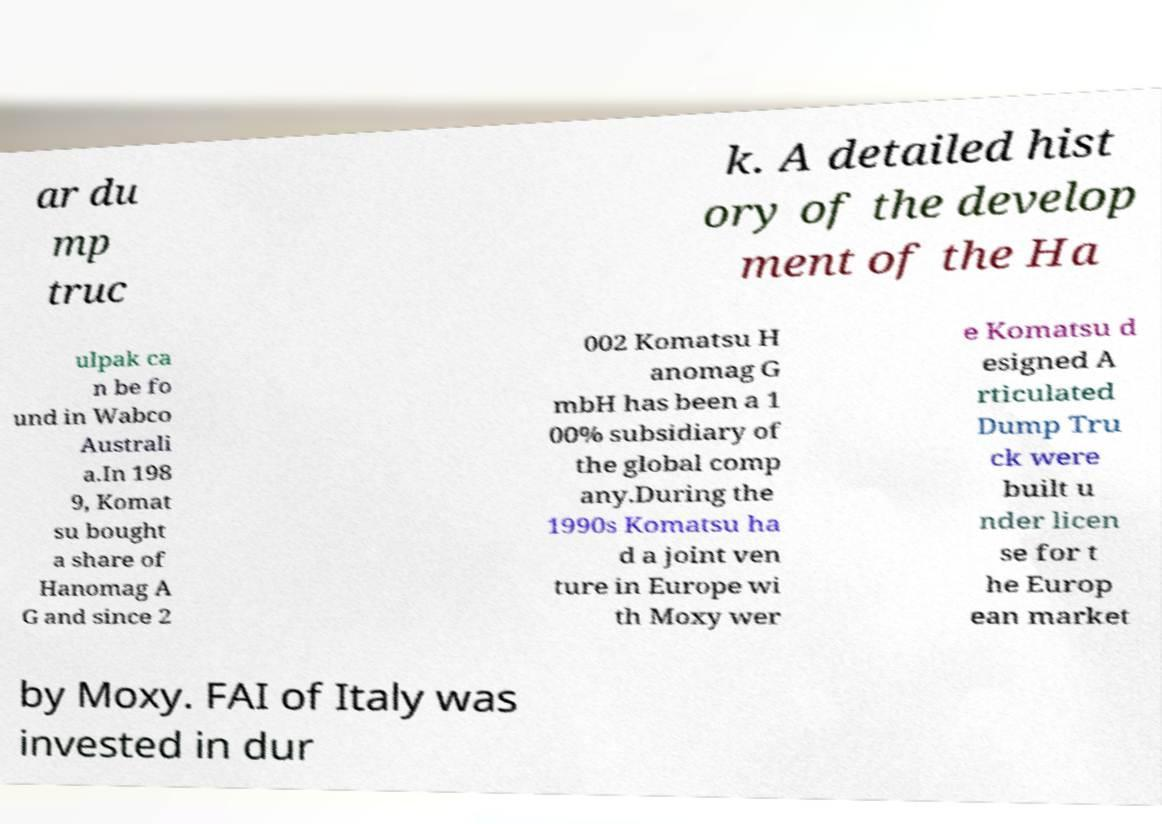What messages or text are displayed in this image? I need them in a readable, typed format. ar du mp truc k. A detailed hist ory of the develop ment of the Ha ulpak ca n be fo und in Wabco Australi a.In 198 9, Komat su bought a share of Hanomag A G and since 2 002 Komatsu H anomag G mbH has been a 1 00% subsidiary of the global comp any.During the 1990s Komatsu ha d a joint ven ture in Europe wi th Moxy wer e Komatsu d esigned A rticulated Dump Tru ck were built u nder licen se for t he Europ ean market by Moxy. FAI of Italy was invested in dur 